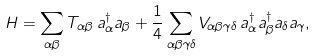Convert formula to latex. <formula><loc_0><loc_0><loc_500><loc_500>H = \sum _ { \alpha \beta } T _ { \alpha \beta } \, a ^ { \dagger } _ { \alpha } a _ { \beta } + \frac { 1 } { 4 } \sum _ { \alpha \beta \gamma \delta } V _ { \alpha \beta \gamma \delta } \, a ^ { \dagger } _ { \alpha } a ^ { \dagger } _ { \beta } a _ { \delta } a _ { \gamma } ,</formula> 